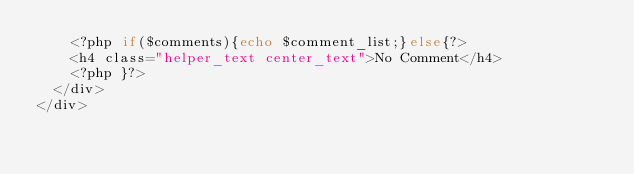<code> <loc_0><loc_0><loc_500><loc_500><_PHP_>		<?php if($comments){echo $comment_list;}else{?>
		<h4 class="helper_text center_text">No Comment</h4>
		<?php }?>
	</div>
</div>

</code> 